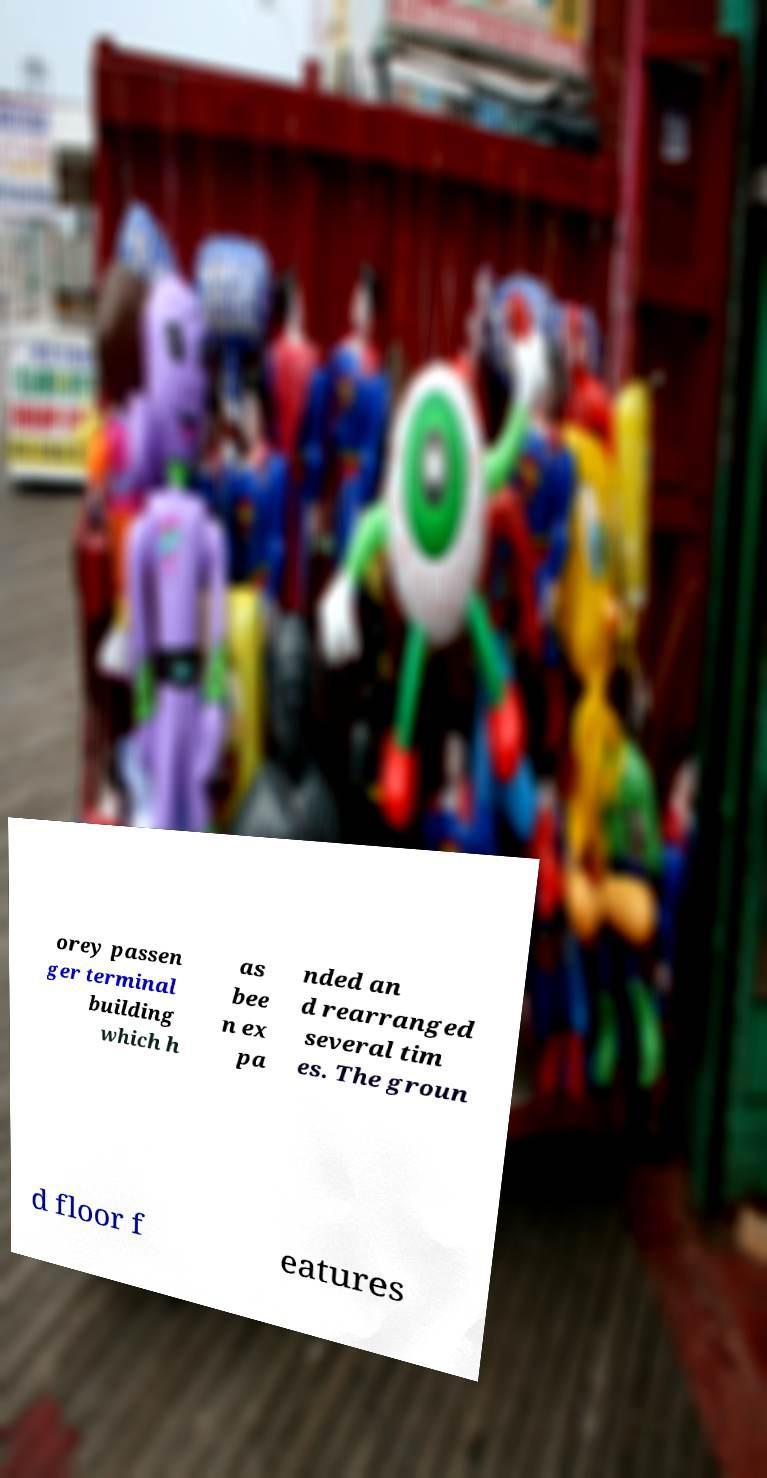Could you extract and type out the text from this image? orey passen ger terminal building which h as bee n ex pa nded an d rearranged several tim es. The groun d floor f eatures 